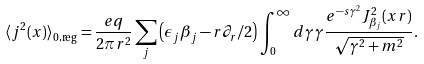<formula> <loc_0><loc_0><loc_500><loc_500>\langle j ^ { 2 } ( x ) \rangle _ { 0 , \text {reg} } = \frac { e q } { 2 \pi r ^ { 2 } } \sum _ { j } \left ( \epsilon _ { j } \beta _ { j } - r \partial _ { r } / 2 \right ) \int _ { 0 } ^ { \infty } d \gamma \, \gamma \frac { e ^ { - s \gamma ^ { 2 } } J _ { \beta _ { j } } ^ { 2 } ( x r ) } { \sqrt { \gamma ^ { 2 } + m ^ { 2 } } } .</formula> 